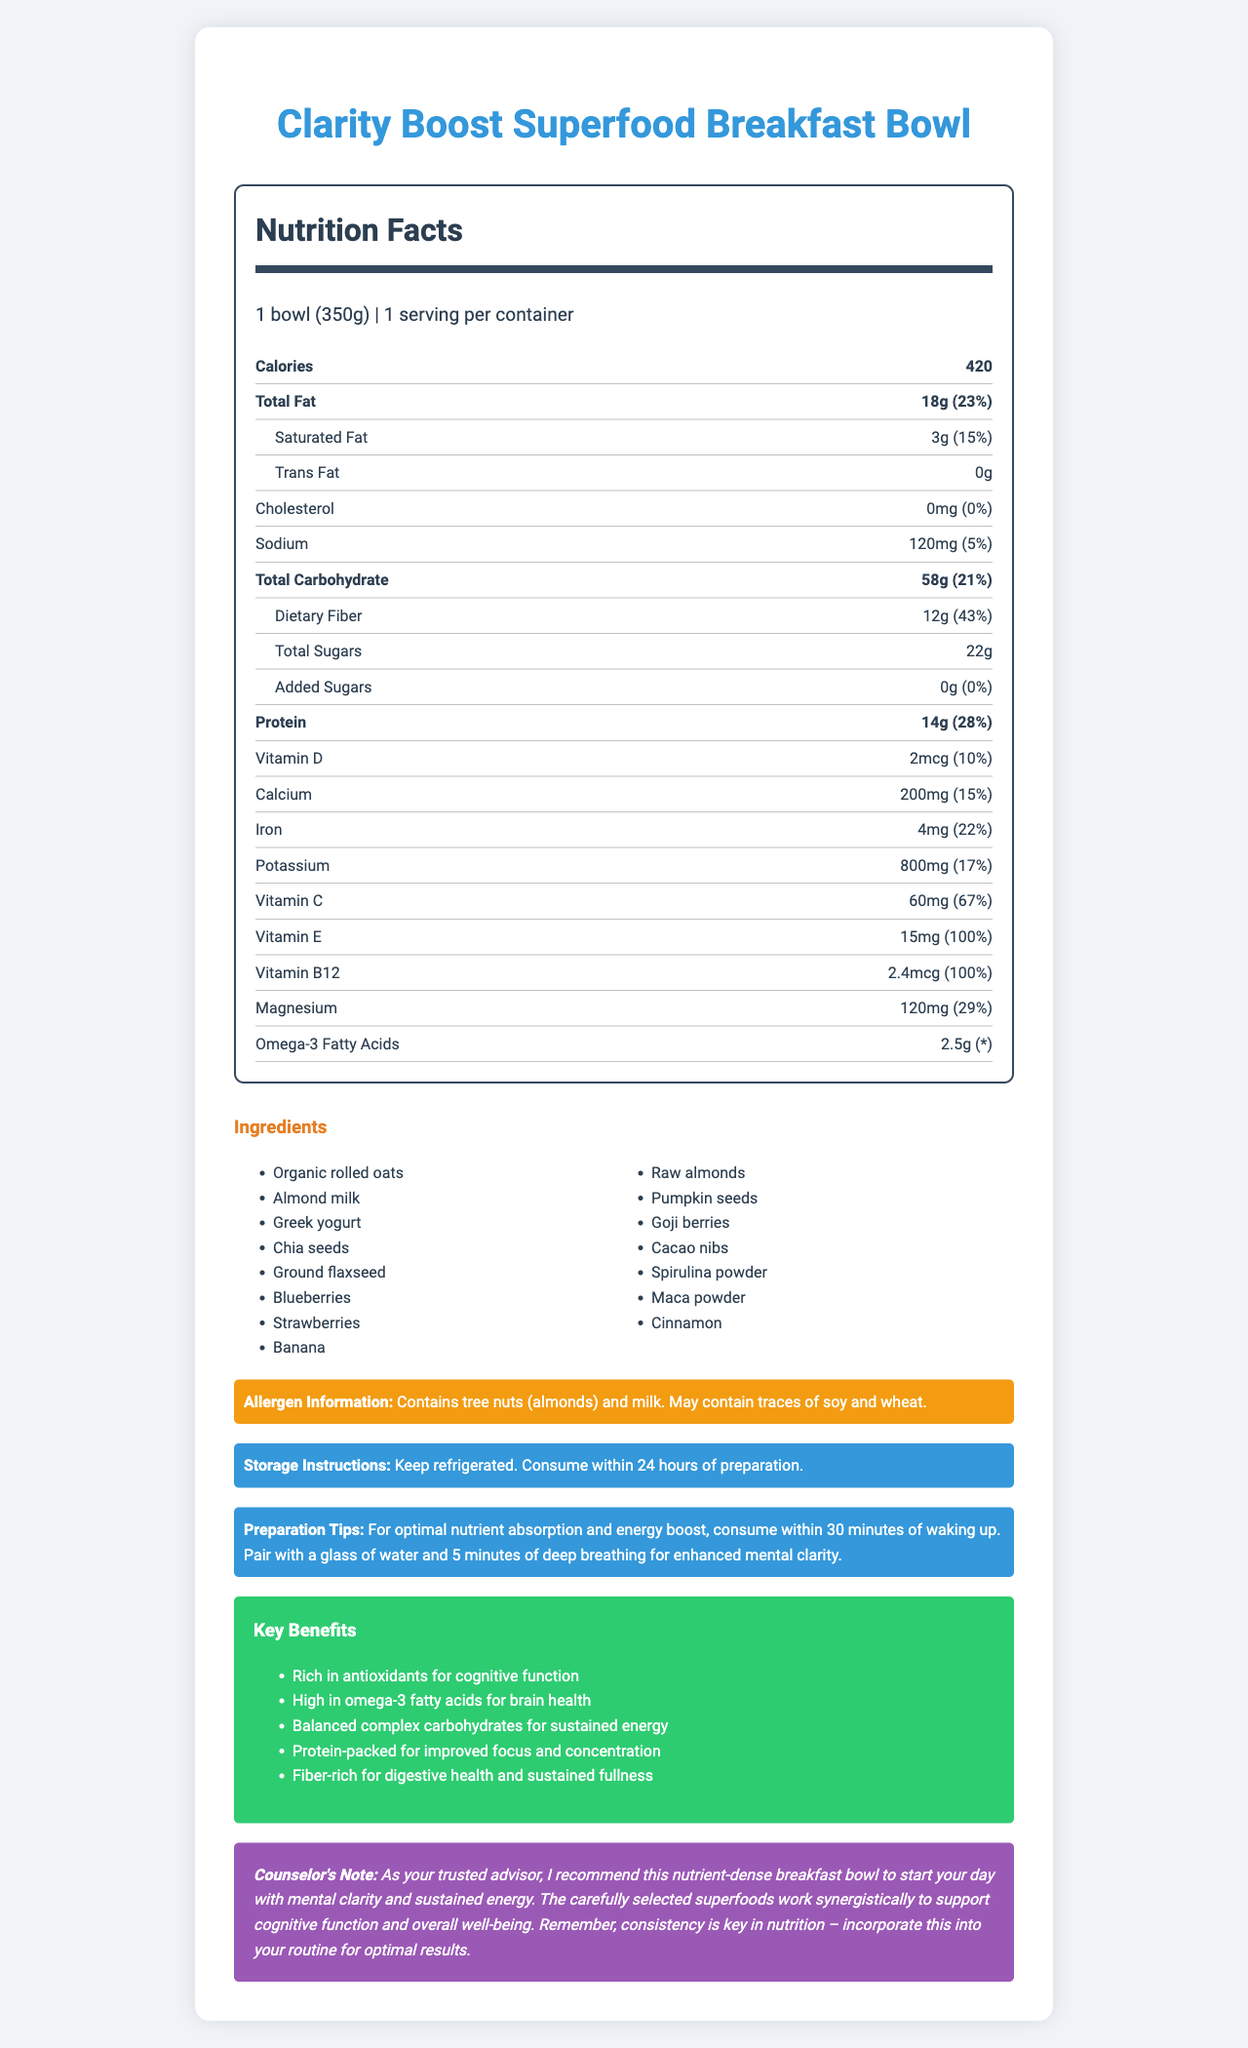what is the serving size? The serving size is stated as "1 bowl (350g)" in the nutrition facts label.
Answer: 1 bowl (350g) how many calories are in one serving? The document specifies that one serving contains 420 calories.
Answer: 420 which nutrient has the highest daily value percentage? From the document, dietary fiber has the highest daily value percentage at 43%.
Answer: Dietary Fiber (43%) list three key ingredients in the breakfast bowl. The listed key ingredients include "Organic rolled oats," "Almond milk," and "Greek yogurt."
Answer: Organic rolled oats, Almond milk, Greek yogurt what are the daily value percentages of vitamin d and calcium? Vitamin D has a daily value percentage of 10%, and Calcium has a daily value percentage of 15%, as mentioned in the nutrition facts.
Answer: Vitamin D: 10%, Calcium: 15% how many grams of total fat are in one serving? A. 10g B. 18g C. 24g D. 30g The total fat content per serving is 18g.
Answer: B. 18g which of the following is not included in the allergen information? 1. Tree nuts 2. Milk 3. Peanuts 4. Soy The allergen information mentions tree nuts (almonds), milk, and possible traces of soy and wheat, but not peanuts.
Answer: 3. Peanuts is there any added sugar in the product? The document states that the added sugars amount is 0g (% daily value is also 0%).
Answer: No does the product contain cholesterol? The cholesterol content is shown as 0mg with a 0% daily value, indicating no cholesterol.
Answer: No summarize the purpose of the document. The main idea of the document is to give detailed information on the Clarity Boost Superfood Breakfast Bowl, including its nutritional benefits and instructions for storage and consumption to maximize its health benefits.
Answer: The document provides a comprehensive nutrient analysis of the Clarity Boost Superfood Breakfast Bowl, highlighting its ingredients, nutritional content, storage instructions, preparation tips, key benefits, and allergen information aimed at promoting mental clarity and energy. how much protein is in the breakfast bowl? The document states that there is 14g of protein in the breakfast bowl.
Answer: 14g what are some preparation tips mentioned? The preparation tips section explains how to consume the breakfast bowl for optimal nutrient absorption and mental clarity.
Answer: Consume within 30 minutes of waking up, pair with a glass of water, and do 5 minutes of deep breathing for enhanced mental clarity. how many ingredients are listed? The ingredients section lists a total of 14 different components used in the breakfast bowl.
Answer: 14 how long can you keep the product refrigerated? The storage instructions specify to keep the product refrigerated and consume it within 24 hours.
Answer: Consume within 24 hours of preparation does the breakfast bowl contribute to brain health? One of the key benefits mentioned is that it is high in omega-3 fatty acids, which are beneficial for brain health.
Answer: Yes which vitamin has the highest daily value percentage? According to the nutrition facts, Vitamin B12 has a daily value percentage of 100%.
Answer: Vitamin B12 (100%) can the breakfast bowl be frozen? The document does not provide any information about freezing the breakfast bowl, only refrigeration is mentioned.
Answer: Not enough information 